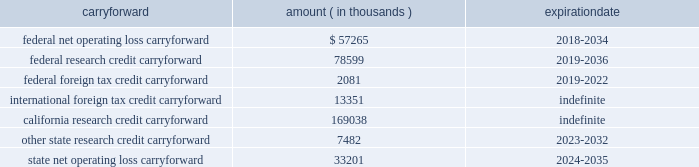Synopsys , inc .
Notes to consolidated financial statements 2014continued the company has the following tax loss and credit carryforwards available to offset future income tax liabilities : carryforward amount expiration ( in thousands ) .
The federal and state net operating loss carryforward is from acquired companies and the annual use of such loss is subject to significant limitations under internal revenue code section 382 .
Foreign tax credits may only be used to offset tax attributable to foreign source income .
The federal research tax credit was permanently reinstated in fiscal 2016 .
The company adopted asu 2016-09 in the first quarter of fiscal 2017 .
The company recorded all income tax effects of share-based awards in its provision for income taxes in the condensed consolidated statement of operations on a prospective basis .
Prior to adoption , the company did not recognize excess tax benefits from stock-based compensation as a charge to capital in excess of par value to the extent that the related tax deduction did not reduce income taxes payable .
Upon adoption of asu 2016-09 , the company recorded a deferred tax asset of $ 106.5 million mainly related to the research tax credit carryover , for the previously unrecognized excess tax benefits with an offsetting adjustment to retained earnings .
Adoption of the new standard resulted in net excess tax benefits in the provision for income taxes of $ 38.1 million for fiscal 2017 .
During the fourth quarter of fiscal 2017 , the company repatriated $ 825 million from its foreign subsidiary .
The repatriation was executed in anticipation of potential u.s .
Corporate tax reform , and the company plans to indefinitely reinvest the remainder of its undistributed foreign earnings outside the united states .
The company provides for u.s .
Income and foreign withholding taxes on foreign earnings , except for foreign earnings that are considered indefinitely reinvested outside the u.s .
As of october 31 , 2017 , there were approximately $ 598.3 million of earnings upon which u.s .
Income taxes of approximately $ 110.0 million have not been provided for. .
What is the variation between the federal research credit carryforward and federal net operating loss carryforward , in thousands? 
Rationale: it is the difference between those values .
Computations: (78599 - 57265)
Answer: 21334.0. 